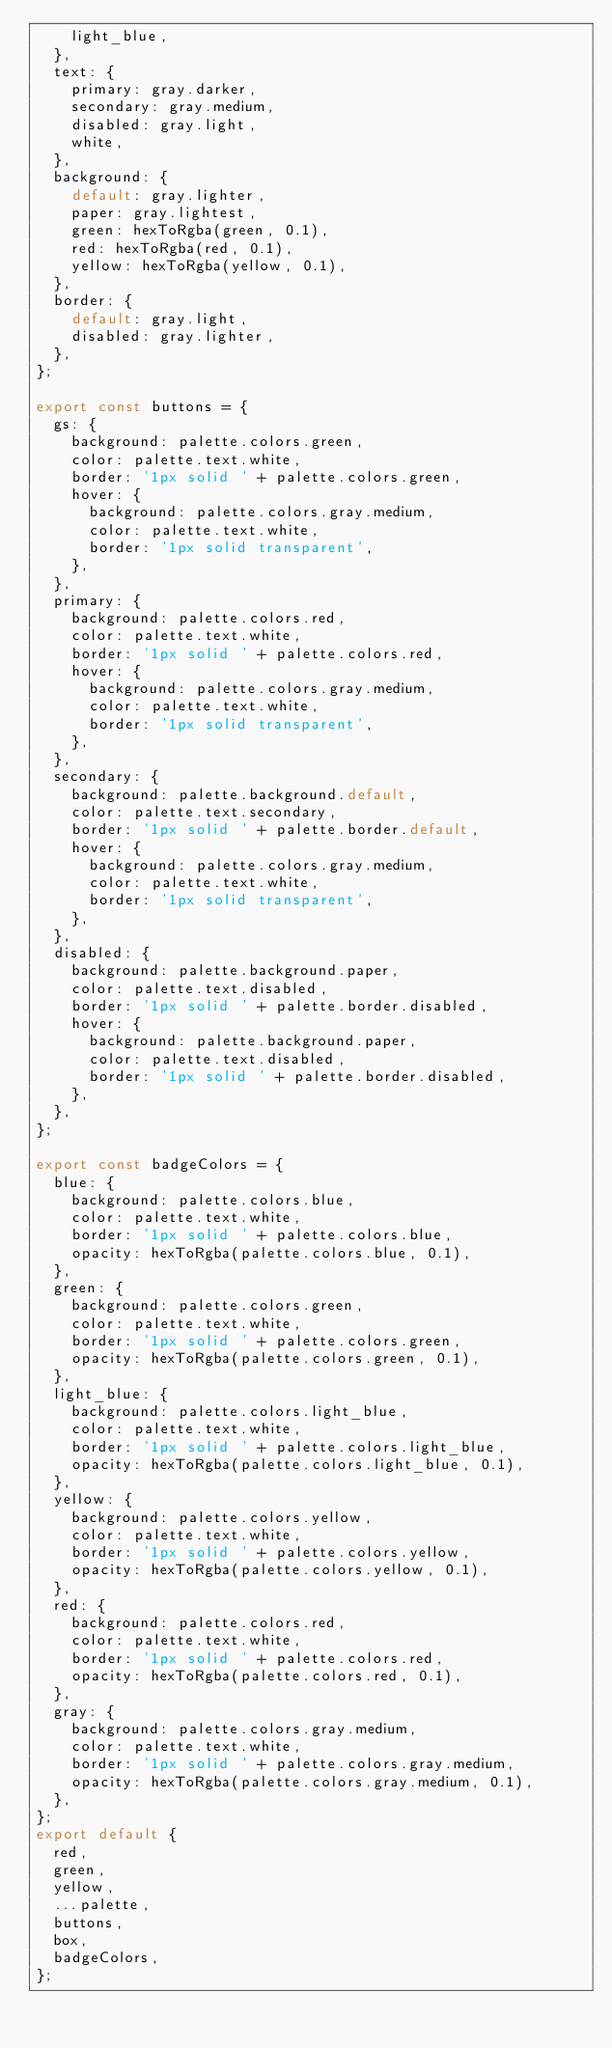<code> <loc_0><loc_0><loc_500><loc_500><_TypeScript_>    light_blue,
  },
  text: {
    primary: gray.darker,
    secondary: gray.medium,
    disabled: gray.light,
    white,
  },
  background: {
    default: gray.lighter,
    paper: gray.lightest,
    green: hexToRgba(green, 0.1),
    red: hexToRgba(red, 0.1),
    yellow: hexToRgba(yellow, 0.1),
  },
  border: {
    default: gray.light,
    disabled: gray.lighter,
  },
};

export const buttons = {
  gs: {
    background: palette.colors.green,
    color: palette.text.white,
    border: '1px solid ' + palette.colors.green,
    hover: {
      background: palette.colors.gray.medium,
      color: palette.text.white,
      border: '1px solid transparent',
    },
  },
  primary: {
    background: palette.colors.red,
    color: palette.text.white,
    border: '1px solid ' + palette.colors.red,
    hover: {
      background: palette.colors.gray.medium,
      color: palette.text.white,
      border: '1px solid transparent',
    },
  },
  secondary: {
    background: palette.background.default,
    color: palette.text.secondary,
    border: '1px solid ' + palette.border.default,
    hover: {
      background: palette.colors.gray.medium,
      color: palette.text.white,
      border: '1px solid transparent',
    },
  },
  disabled: {
    background: palette.background.paper,
    color: palette.text.disabled,
    border: '1px solid ' + palette.border.disabled,
    hover: {
      background: palette.background.paper,
      color: palette.text.disabled,
      border: '1px solid ' + palette.border.disabled,
    },
  },
};

export const badgeColors = {
  blue: {
    background: palette.colors.blue,
    color: palette.text.white,
    border: '1px solid ' + palette.colors.blue,
    opacity: hexToRgba(palette.colors.blue, 0.1),
  },
  green: {
    background: palette.colors.green,
    color: palette.text.white,
    border: '1px solid ' + palette.colors.green,
    opacity: hexToRgba(palette.colors.green, 0.1),
  },
  light_blue: {
    background: palette.colors.light_blue,
    color: palette.text.white,
    border: '1px solid ' + palette.colors.light_blue,
    opacity: hexToRgba(palette.colors.light_blue, 0.1),
  },
  yellow: {
    background: palette.colors.yellow,
    color: palette.text.white,
    border: '1px solid ' + palette.colors.yellow,
    opacity: hexToRgba(palette.colors.yellow, 0.1),
  },
  red: {
    background: palette.colors.red,
    color: palette.text.white,
    border: '1px solid ' + palette.colors.red,
    opacity: hexToRgba(palette.colors.red, 0.1),
  },
  gray: {
    background: palette.colors.gray.medium,
    color: palette.text.white,
    border: '1px solid ' + palette.colors.gray.medium,
    opacity: hexToRgba(palette.colors.gray.medium, 0.1),
  },
};
export default {
  red,
  green,
  yellow,
  ...palette,
  buttons,
  box,
  badgeColors,
};
</code> 